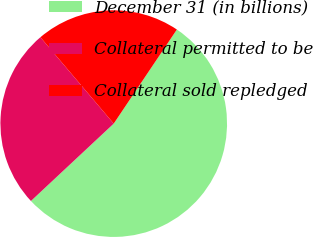Convert chart to OTSL. <chart><loc_0><loc_0><loc_500><loc_500><pie_chart><fcel>December 31 (in billions)<fcel>Collateral permitted to be<fcel>Collateral sold repledged<nl><fcel>53.63%<fcel>25.76%<fcel>20.61%<nl></chart> 